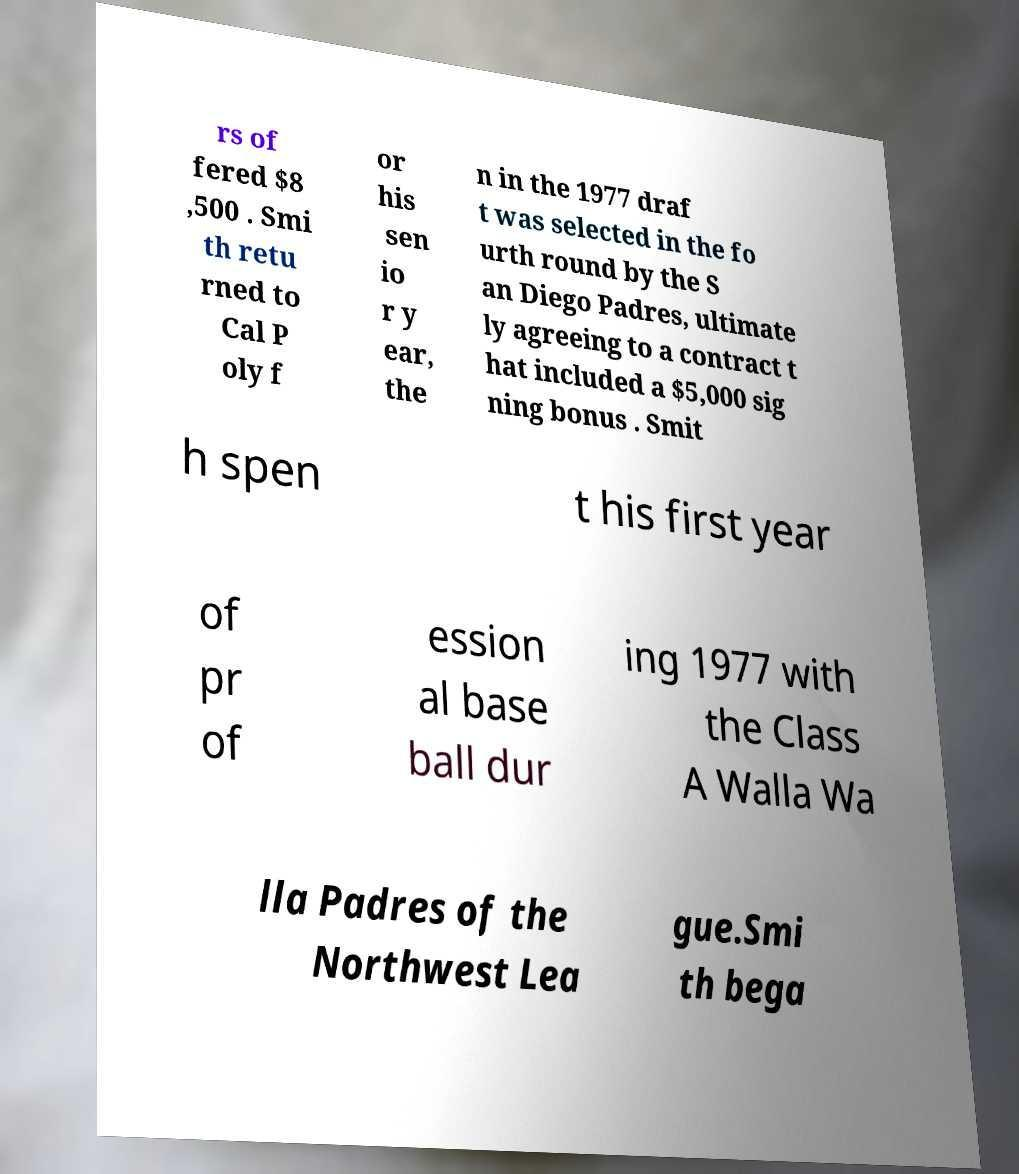Could you assist in decoding the text presented in this image and type it out clearly? rs of fered $8 ,500 . Smi th retu rned to Cal P oly f or his sen io r y ear, the n in the 1977 draf t was selected in the fo urth round by the S an Diego Padres, ultimate ly agreeing to a contract t hat included a $5,000 sig ning bonus . Smit h spen t his first year of pr of ession al base ball dur ing 1977 with the Class A Walla Wa lla Padres of the Northwest Lea gue.Smi th bega 